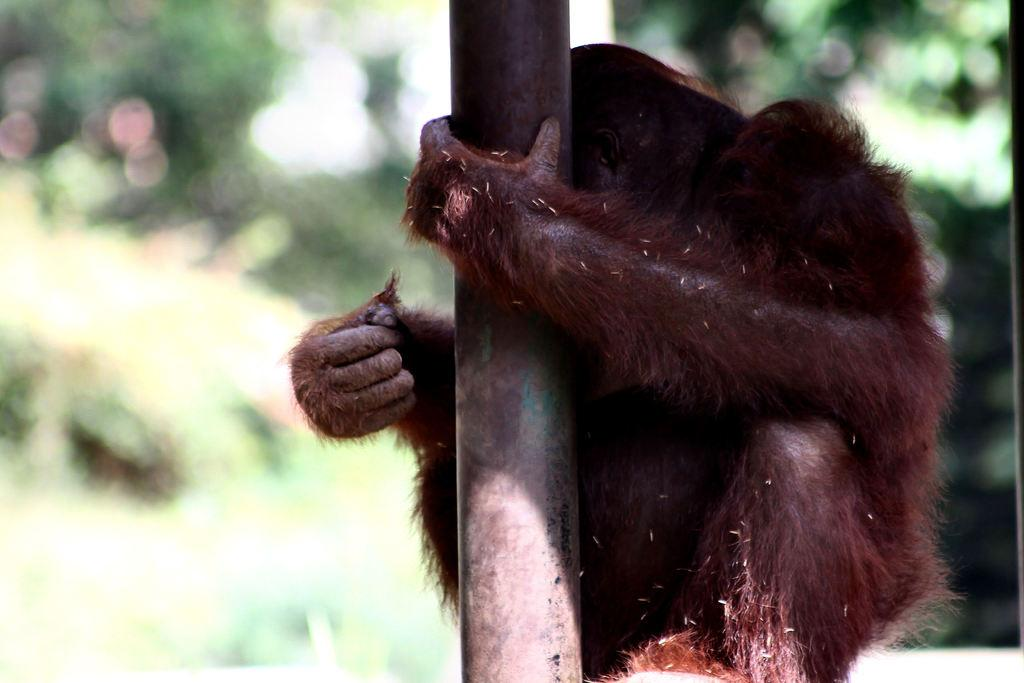What animal is present in the image? There is a monkey in the image. Where is the monkey located? The monkey is at a pole. What type of root can be seen growing from the goose in the image? There is no goose present in the image, so there cannot be any roots growing from it. 